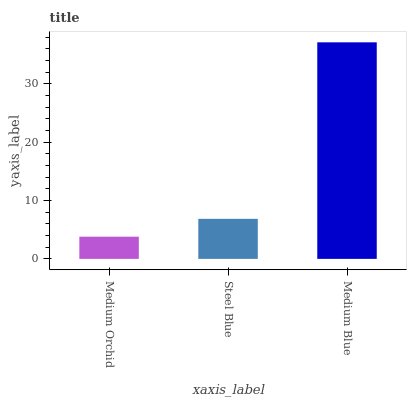Is Medium Orchid the minimum?
Answer yes or no. Yes. Is Medium Blue the maximum?
Answer yes or no. Yes. Is Steel Blue the minimum?
Answer yes or no. No. Is Steel Blue the maximum?
Answer yes or no. No. Is Steel Blue greater than Medium Orchid?
Answer yes or no. Yes. Is Medium Orchid less than Steel Blue?
Answer yes or no. Yes. Is Medium Orchid greater than Steel Blue?
Answer yes or no. No. Is Steel Blue less than Medium Orchid?
Answer yes or no. No. Is Steel Blue the high median?
Answer yes or no. Yes. Is Steel Blue the low median?
Answer yes or no. Yes. Is Medium Blue the high median?
Answer yes or no. No. Is Medium Blue the low median?
Answer yes or no. No. 